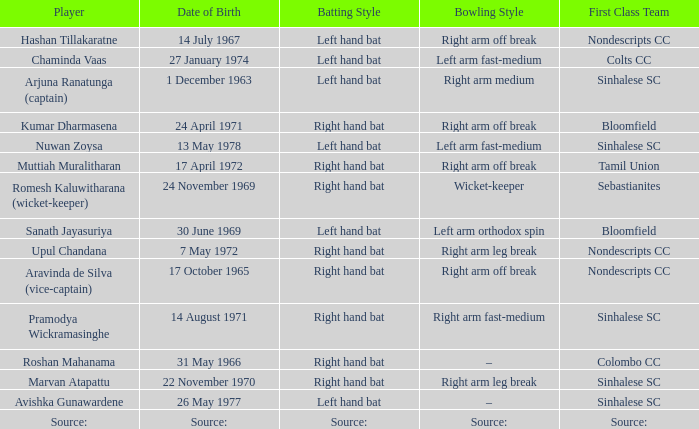What first class team does sanath jayasuriya play for? Bloomfield. 